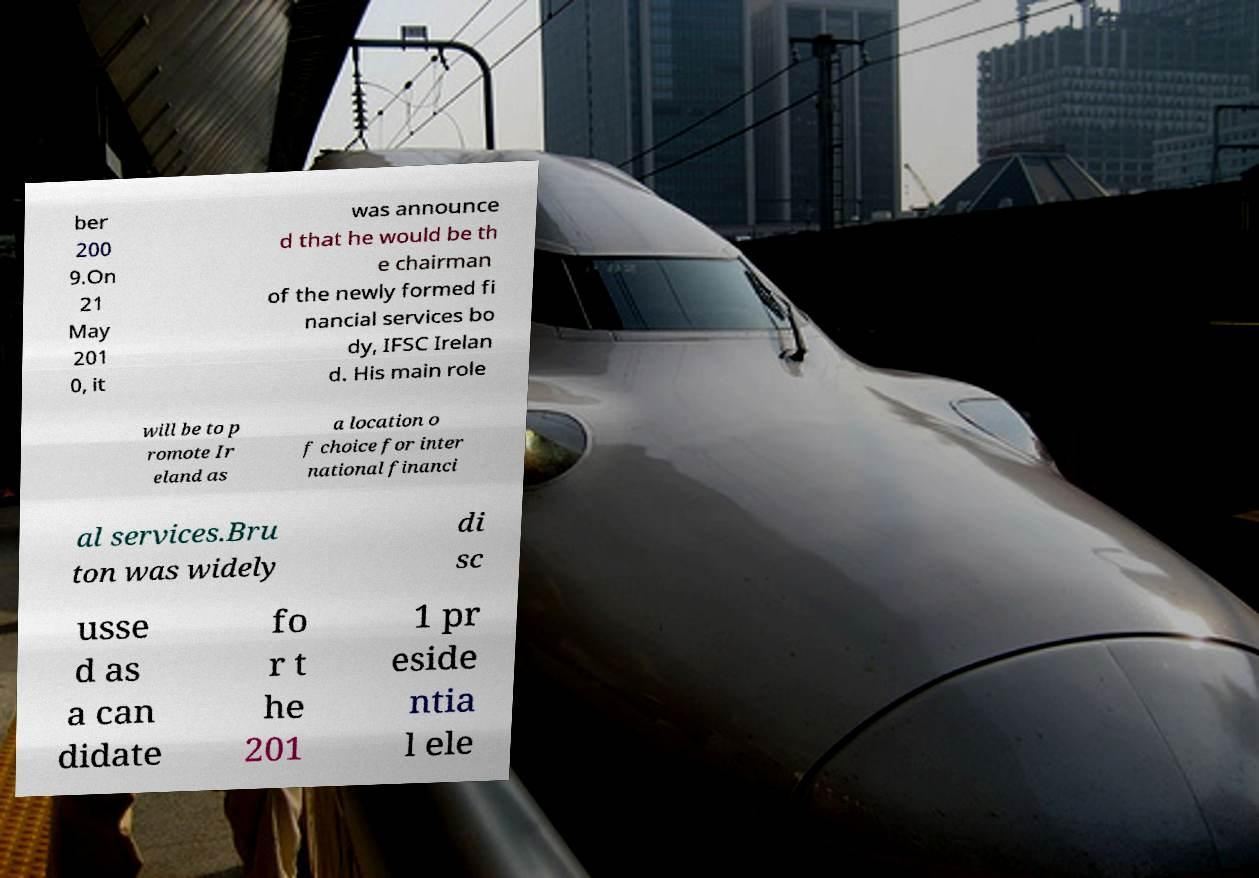Can you read and provide the text displayed in the image?This photo seems to have some interesting text. Can you extract and type it out for me? ber 200 9.On 21 May 201 0, it was announce d that he would be th e chairman of the newly formed fi nancial services bo dy, IFSC Irelan d. His main role will be to p romote Ir eland as a location o f choice for inter national financi al services.Bru ton was widely di sc usse d as a can didate fo r t he 201 1 pr eside ntia l ele 